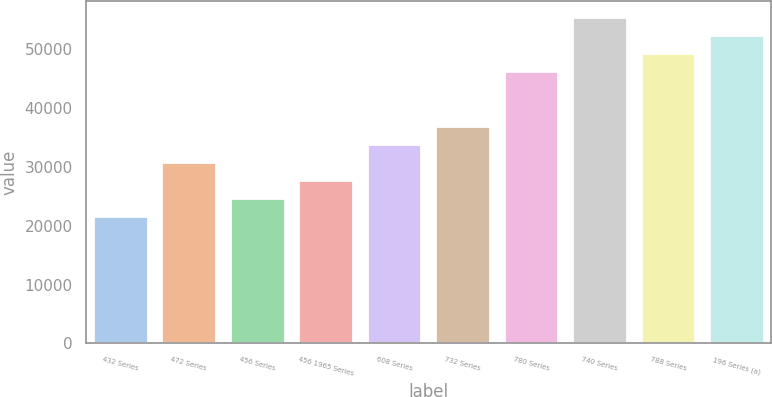Convert chart to OTSL. <chart><loc_0><loc_0><loc_500><loc_500><bar_chart><fcel>432 Series<fcel>472 Series<fcel>456 Series<fcel>456 1965 Series<fcel>608 Series<fcel>732 Series<fcel>780 Series<fcel>740 Series<fcel>788 Series<fcel>196 Series (a)<nl><fcel>21667.9<fcel>30883<fcel>24739.6<fcel>27811.3<fcel>33954.7<fcel>37026.4<fcel>46241.5<fcel>55456.6<fcel>49313.2<fcel>52384.9<nl></chart> 